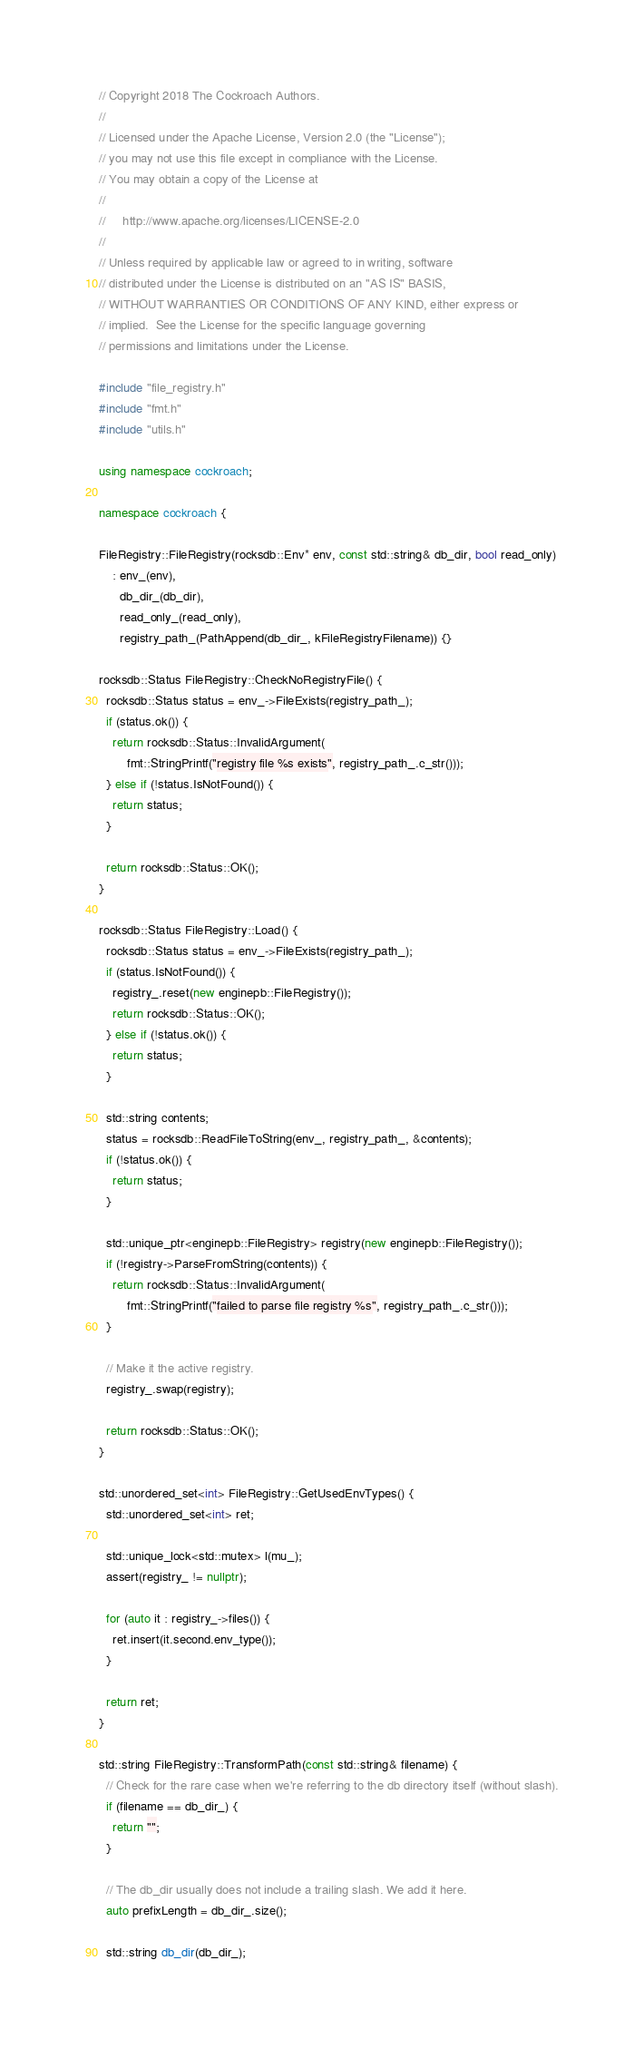<code> <loc_0><loc_0><loc_500><loc_500><_C++_>// Copyright 2018 The Cockroach Authors.
//
// Licensed under the Apache License, Version 2.0 (the "License");
// you may not use this file except in compliance with the License.
// You may obtain a copy of the License at
//
//     http://www.apache.org/licenses/LICENSE-2.0
//
// Unless required by applicable law or agreed to in writing, software
// distributed under the License is distributed on an "AS IS" BASIS,
// WITHOUT WARRANTIES OR CONDITIONS OF ANY KIND, either express or
// implied.  See the License for the specific language governing
// permissions and limitations under the License.

#include "file_registry.h"
#include "fmt.h"
#include "utils.h"

using namespace cockroach;

namespace cockroach {

FileRegistry::FileRegistry(rocksdb::Env* env, const std::string& db_dir, bool read_only)
    : env_(env),
      db_dir_(db_dir),
      read_only_(read_only),
      registry_path_(PathAppend(db_dir_, kFileRegistryFilename)) {}

rocksdb::Status FileRegistry::CheckNoRegistryFile() {
  rocksdb::Status status = env_->FileExists(registry_path_);
  if (status.ok()) {
    return rocksdb::Status::InvalidArgument(
        fmt::StringPrintf("registry file %s exists", registry_path_.c_str()));
  } else if (!status.IsNotFound()) {
    return status;
  }

  return rocksdb::Status::OK();
}

rocksdb::Status FileRegistry::Load() {
  rocksdb::Status status = env_->FileExists(registry_path_);
  if (status.IsNotFound()) {
    registry_.reset(new enginepb::FileRegistry());
    return rocksdb::Status::OK();
  } else if (!status.ok()) {
    return status;
  }

  std::string contents;
  status = rocksdb::ReadFileToString(env_, registry_path_, &contents);
  if (!status.ok()) {
    return status;
  }

  std::unique_ptr<enginepb::FileRegistry> registry(new enginepb::FileRegistry());
  if (!registry->ParseFromString(contents)) {
    return rocksdb::Status::InvalidArgument(
        fmt::StringPrintf("failed to parse file registry %s", registry_path_.c_str()));
  }

  // Make it the active registry.
  registry_.swap(registry);

  return rocksdb::Status::OK();
}

std::unordered_set<int> FileRegistry::GetUsedEnvTypes() {
  std::unordered_set<int> ret;

  std::unique_lock<std::mutex> l(mu_);
  assert(registry_ != nullptr);

  for (auto it : registry_->files()) {
    ret.insert(it.second.env_type());
  }

  return ret;
}

std::string FileRegistry::TransformPath(const std::string& filename) {
  // Check for the rare case when we're referring to the db directory itself (without slash).
  if (filename == db_dir_) {
    return "";
  }

  // The db_dir usually does not include a trailing slash. We add it here.
  auto prefixLength = db_dir_.size();

  std::string db_dir(db_dir_);</code> 